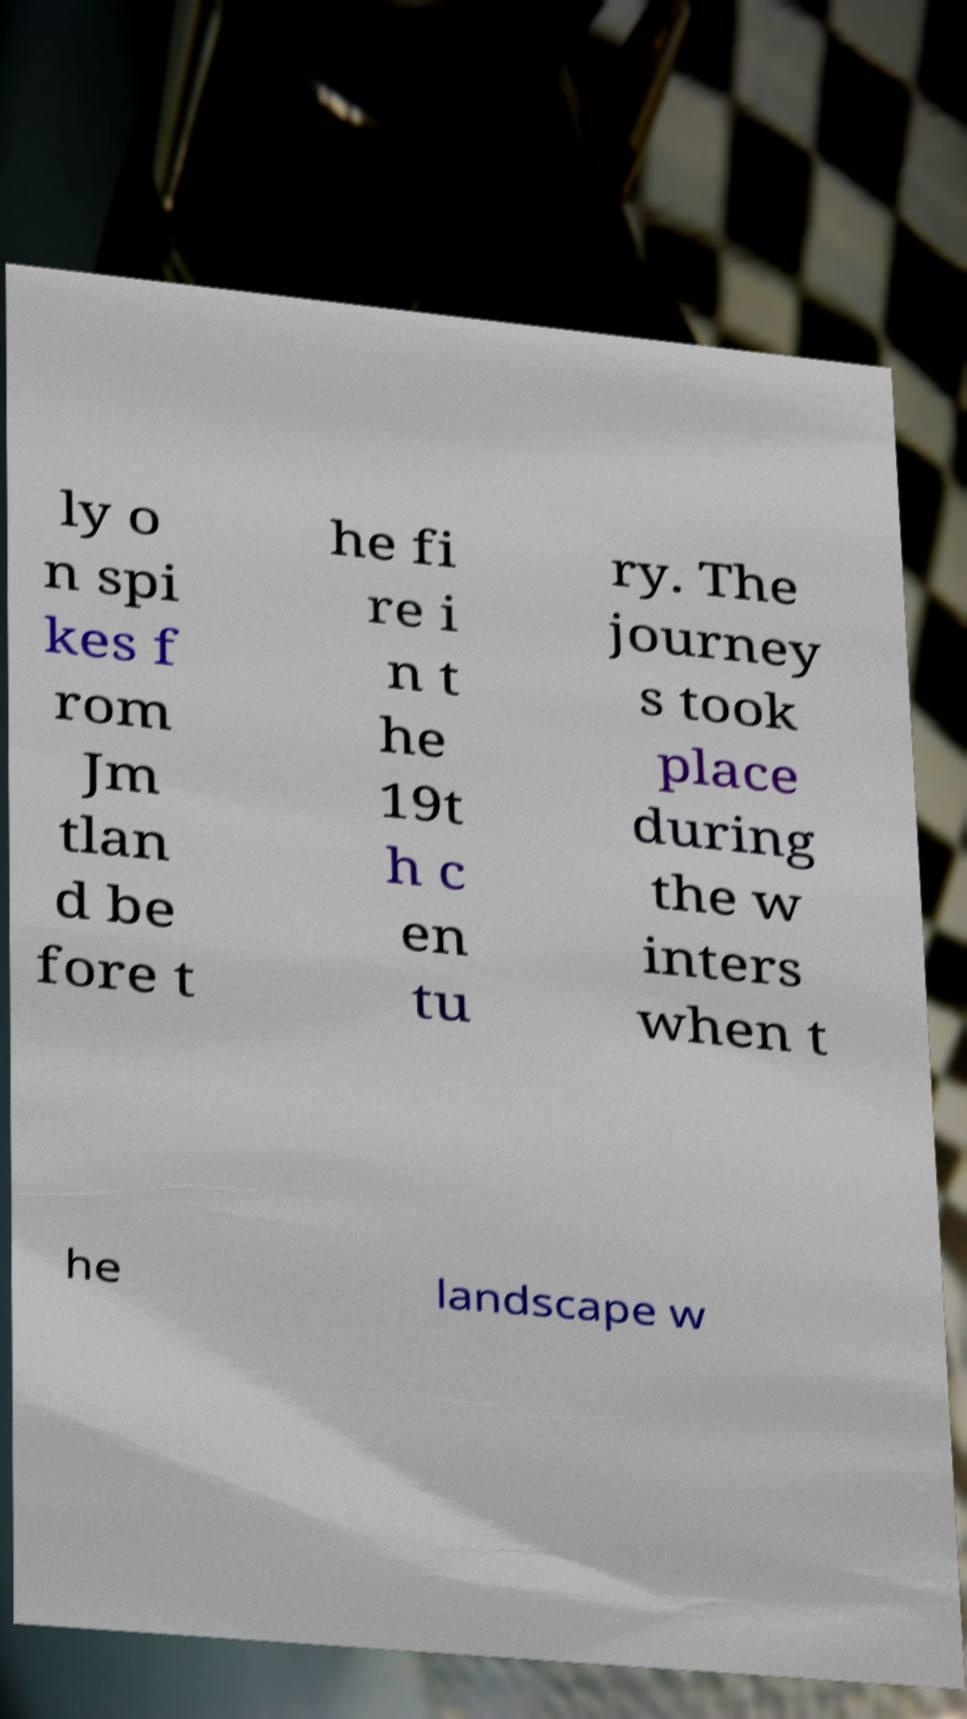There's text embedded in this image that I need extracted. Can you transcribe it verbatim? ly o n spi kes f rom Jm tlan d be fore t he fi re i n t he 19t h c en tu ry. The journey s took place during the w inters when t he landscape w 